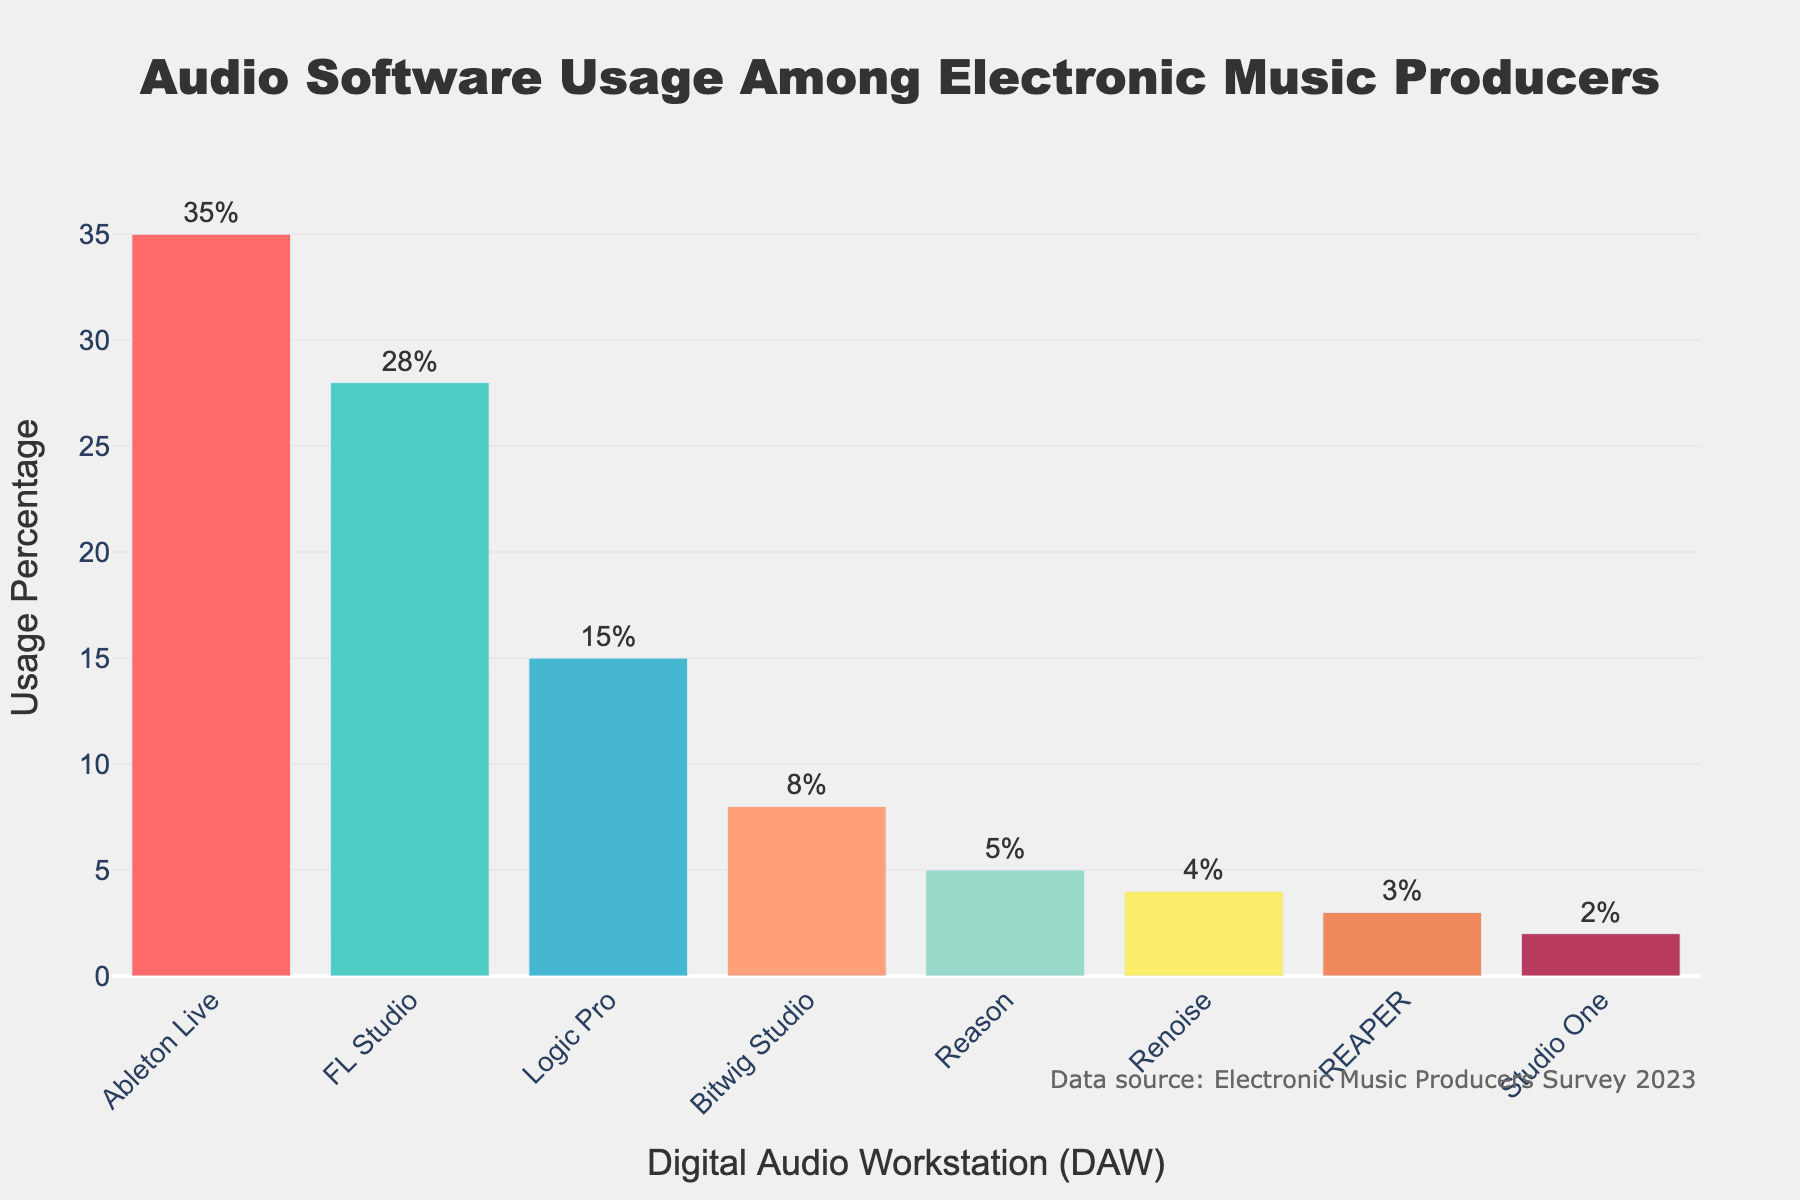Which DAW is the most popular among electronic music producers? The bar chart shows the usage percentage for various DAWs, and the tallest bar corresponds to Ableton Live.
Answer: Ableton Live What is the total percentage usage of Bitwig Studio, Reason, and Renoise? Sum the percentages of Bitwig Studio (8%), Reason (5%), and Renoise (4%): 8 + 5 + 4 = 17%.
Answer: 17% Which two DAWs have the closest usage percentages? By examining the heights of the bars, FL Studio (28%) and Logic Pro (15%) seem to have a significant difference. Bitwig Studio (8%) and Reason (5%) are closer, but the closest are Reason (5%) and Renoise (4%) with only a 1% difference.
Answer: Reason and Renoise How much more popular is Ableton Live than FL Studio? Subtract the percentage of FL Studio (28%) from Ableton Live (35%): 35 - 28 = 7%.
Answer: 7% What is the combined usage percentage of the top three DAWs? Sum the percentages of Ableton Live (35%), FL Studio (28%), and Logic Pro (15%): 35 + 28 + 15 = 78%.
Answer: 78% Which DAW has the second-lowest usage percentage? The DAW with the second-lowest percentage is REAPER (3%), as the lowest is Studio One (2%).
Answer: REAPER What is the average usage percentage of all the DAWs listed? Sum all the percentages: 35 + 28 + 15 + 8 + 5 + 4 + 3 + 2 = 100, then divide by the number of DAWs: 100 / 8 = 12.5%.
Answer: 12.5% Which DAW has the smallest usage, and what is its percentage? The shortest bar corresponds to Studio One with a usage percentage of 2%.
Answer: Studio One, 2% Are there any DAWs used by more than 30% of producers? If yes, which one(s)? Ableton Live is the only DAW used by more than 30% of producers, as it has a percentage of 35%.
Answer: Ableton Live What is the percentage difference between the least used DAW and the second most used DAW? Subtract the percentage of Studio One (2%) from FL Studio (28%): 28 - 2 = 26%.
Answer: 26% 